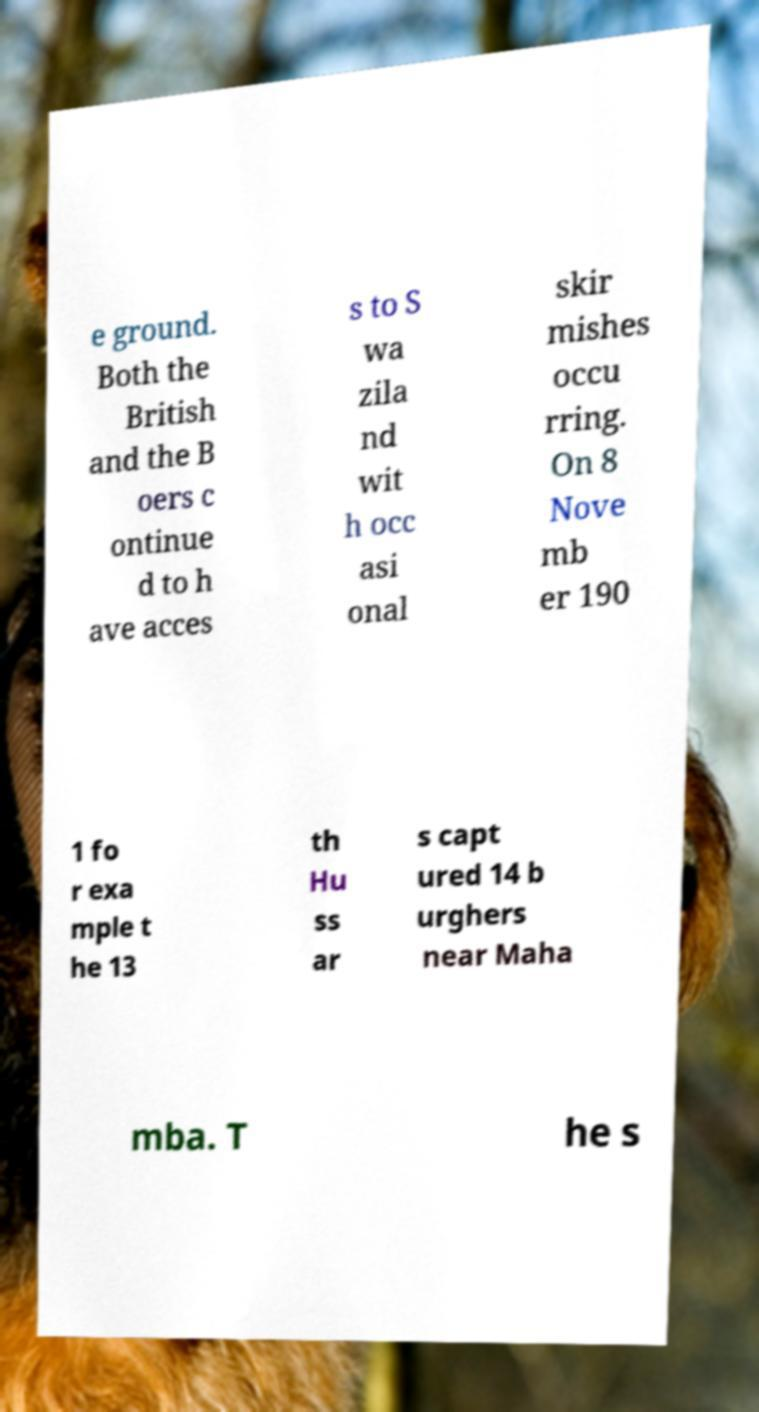I need the written content from this picture converted into text. Can you do that? e ground. Both the British and the B oers c ontinue d to h ave acces s to S wa zila nd wit h occ asi onal skir mishes occu rring. On 8 Nove mb er 190 1 fo r exa mple t he 13 th Hu ss ar s capt ured 14 b urghers near Maha mba. T he s 